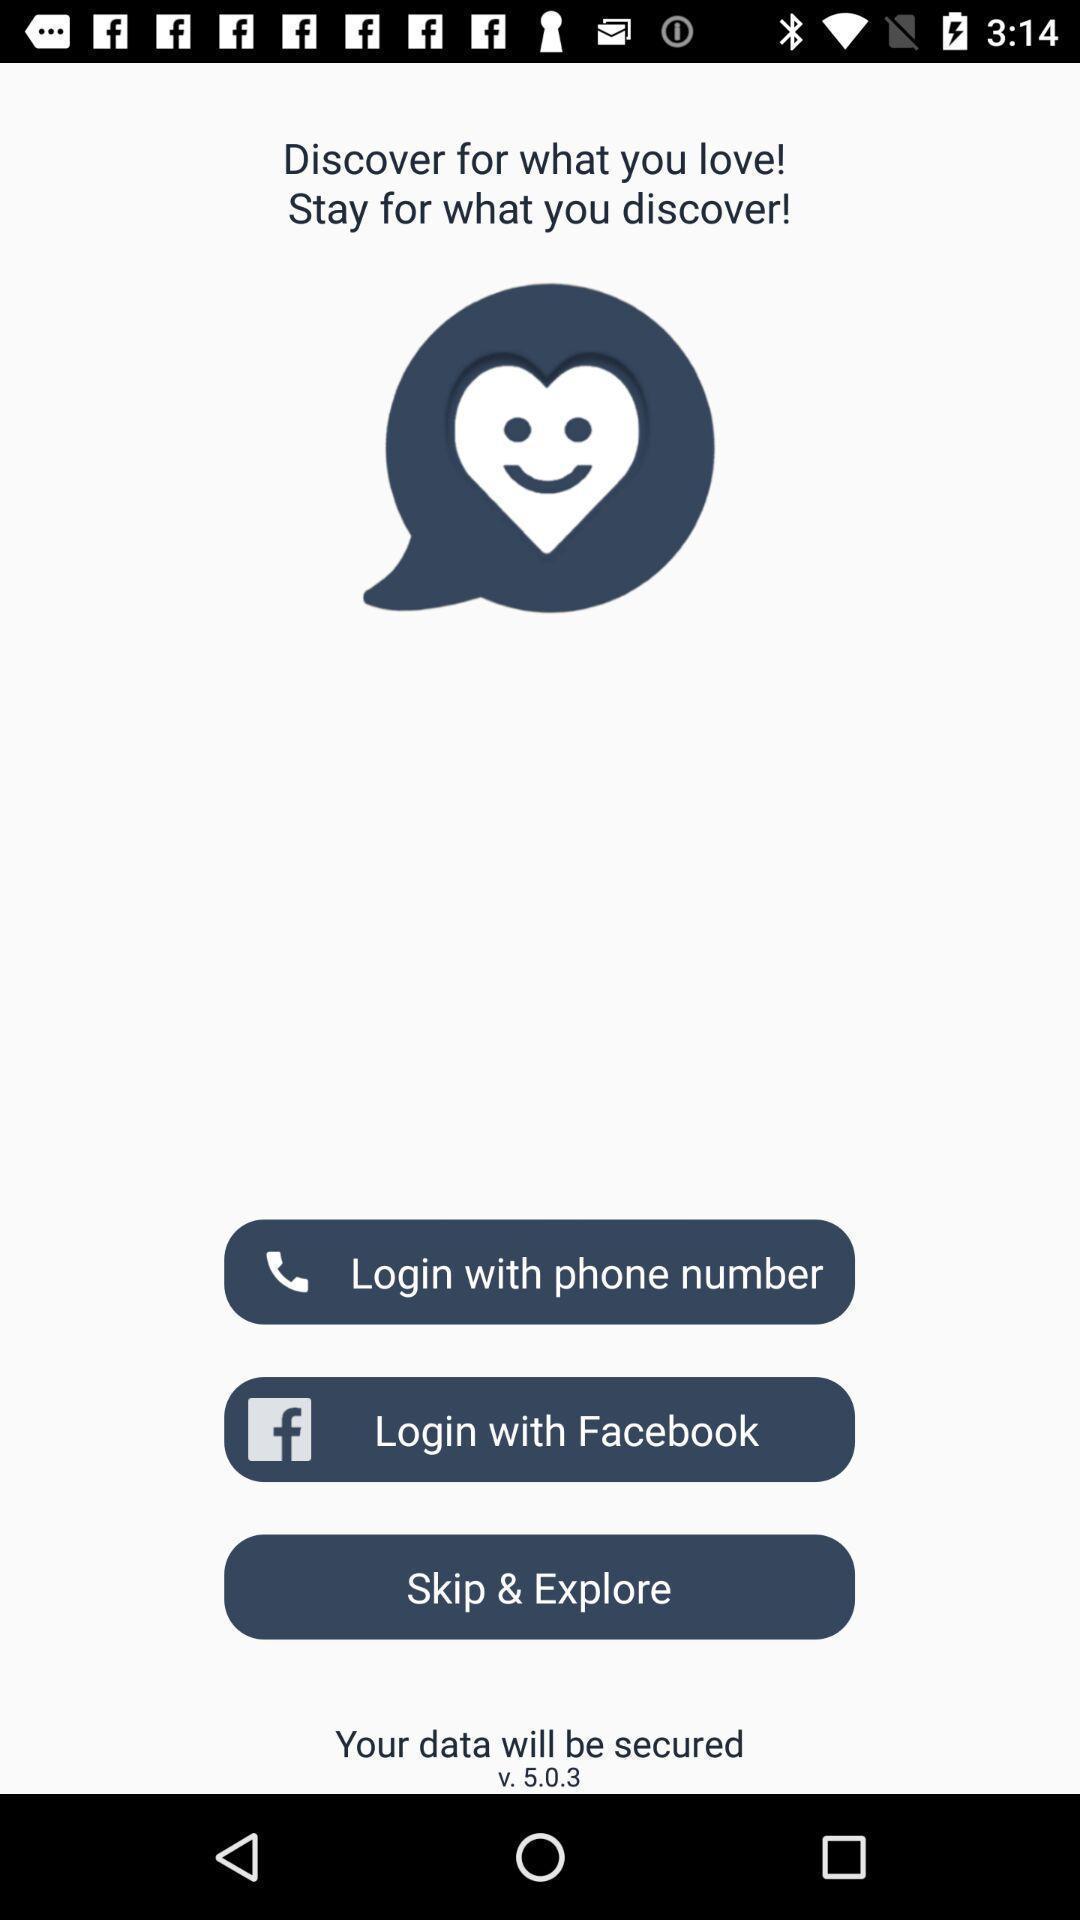Give me a narrative description of this picture. Welcome page displaying login details. 